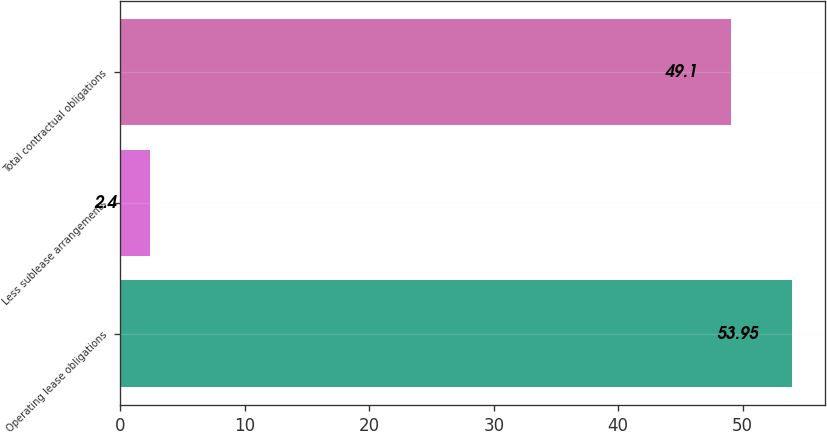<chart> <loc_0><loc_0><loc_500><loc_500><bar_chart><fcel>Operating lease obligations<fcel>Less sublease arrangements<fcel>Total contractual obligations<nl><fcel>53.95<fcel>2.4<fcel>49.1<nl></chart> 